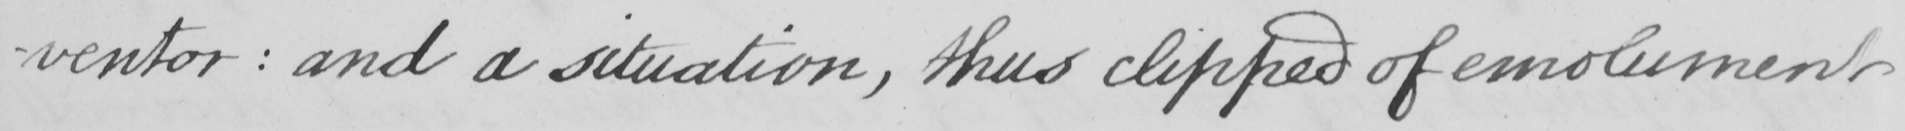Can you tell me what this handwritten text says? -ventor :  and a situation , thus clipped of emoluments 